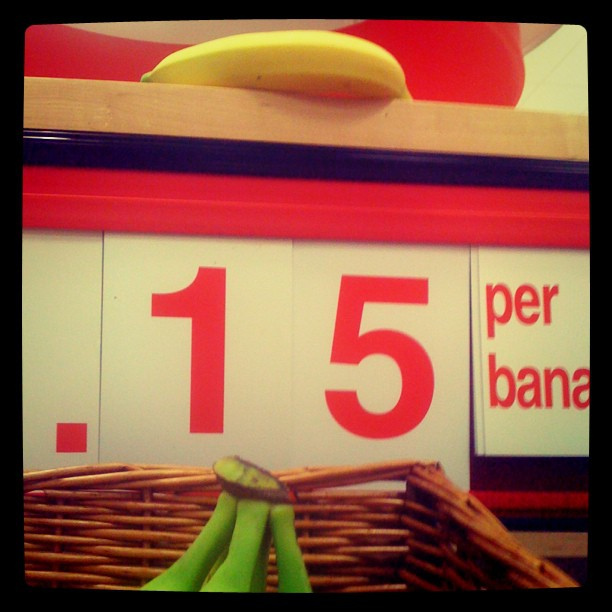Please identify all text content in this image. . 1 5 per bana 